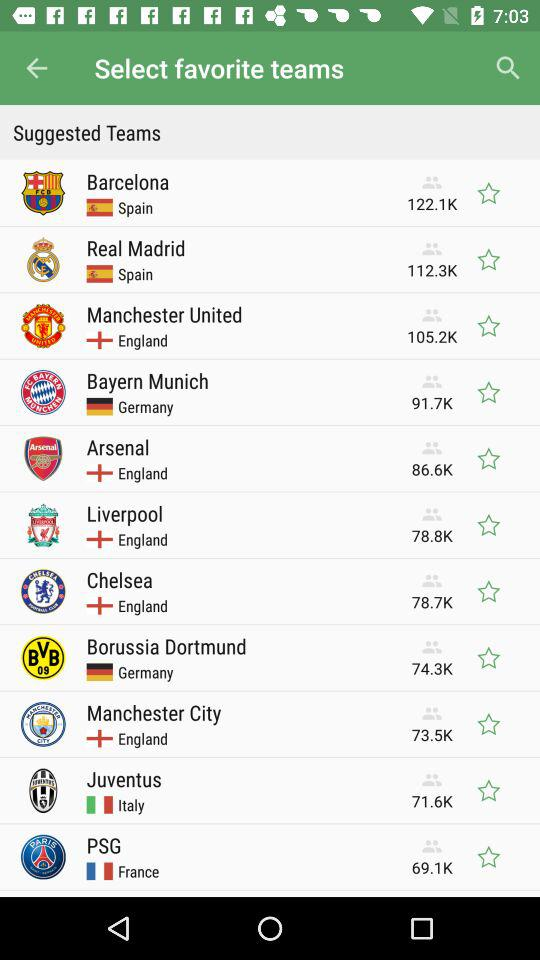How many people follow "Liverpool"? The number of people who follow "Liverpool" is 78.8K. 